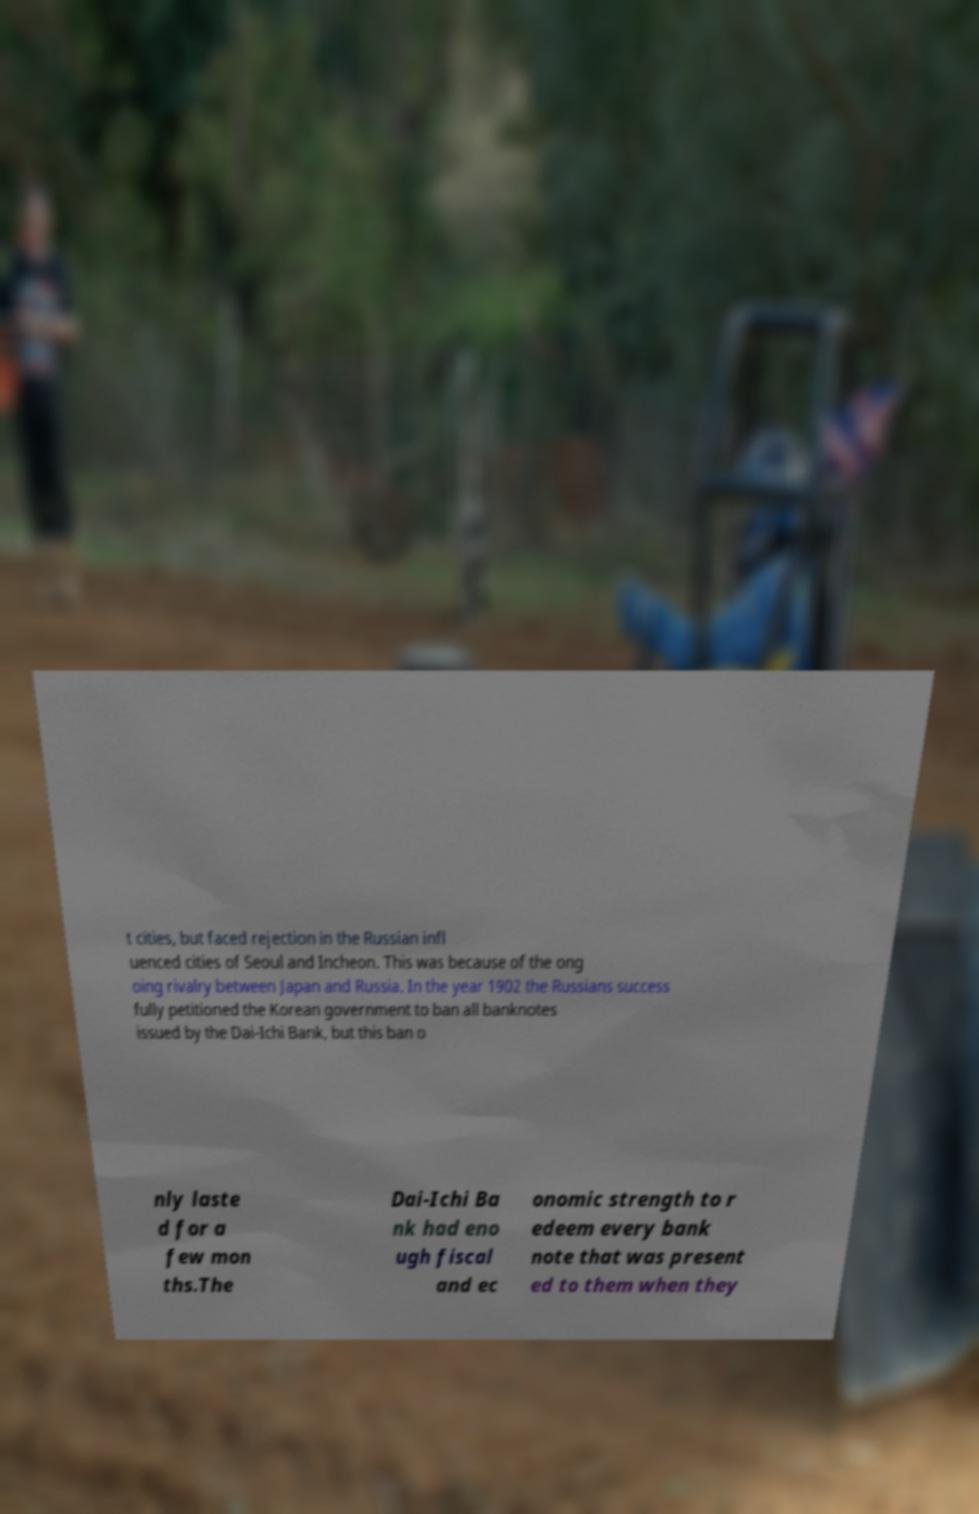There's text embedded in this image that I need extracted. Can you transcribe it verbatim? t cities, but faced rejection in the Russian infl uenced cities of Seoul and Incheon. This was because of the ong oing rivalry between Japan and Russia. In the year 1902 the Russians success fully petitioned the Korean government to ban all banknotes issued by the Dai-Ichi Bank, but this ban o nly laste d for a few mon ths.The Dai-Ichi Ba nk had eno ugh fiscal and ec onomic strength to r edeem every bank note that was present ed to them when they 